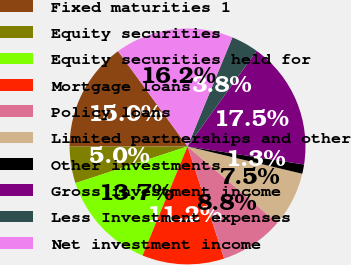Convert chart. <chart><loc_0><loc_0><loc_500><loc_500><pie_chart><fcel>Fixed maturities 1<fcel>Equity securities<fcel>Equity securities held for<fcel>Mortgage loans<fcel>Policy loans<fcel>Limited partnerships and other<fcel>Other investments<fcel>Gross investment income<fcel>Less Investment expenses<fcel>Net investment income<nl><fcel>14.99%<fcel>5.01%<fcel>13.74%<fcel>11.25%<fcel>8.75%<fcel>7.51%<fcel>1.27%<fcel>17.48%<fcel>3.76%<fcel>16.24%<nl></chart> 